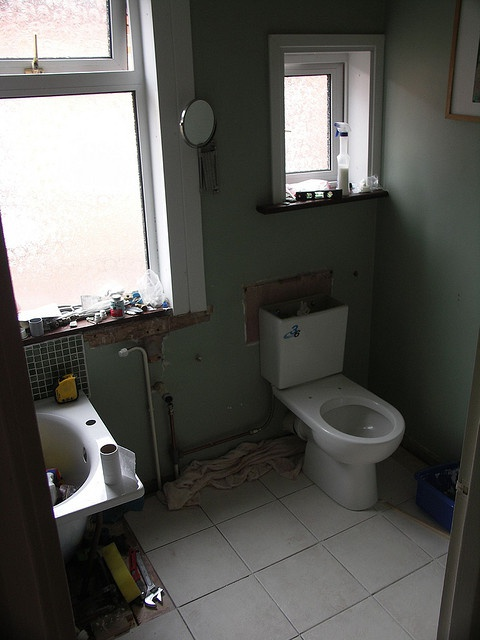Describe the objects in this image and their specific colors. I can see toilet in pink, gray, and black tones and sink in pink, gray, black, white, and darkgray tones in this image. 